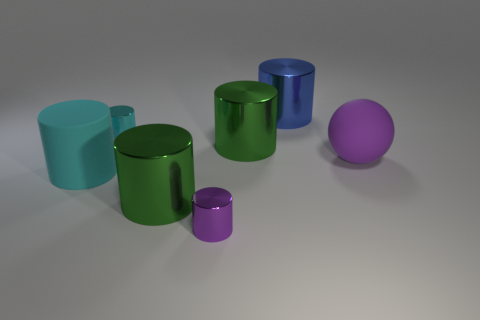Is the number of blue shiny objects that are behind the large cyan cylinder less than the number of big purple spheres behind the blue object?
Your answer should be very brief. No. What is the shape of the large shiny object that is both in front of the cyan metallic cylinder and behind the large purple rubber thing?
Provide a succinct answer. Cylinder. There is a purple ball that is the same material as the big cyan thing; what size is it?
Your answer should be very brief. Large. There is a large rubber sphere; is it the same color as the small cylinder that is behind the large cyan thing?
Your response must be concise. No. There is a large thing that is both in front of the large sphere and to the right of the big cyan matte cylinder; what is its material?
Ensure brevity in your answer.  Metal. There is a object that is the same color as the large rubber cylinder; what is its size?
Make the answer very short. Small. Is the shape of the green thing that is to the right of the purple cylinder the same as the big rubber object on the right side of the tiny purple thing?
Keep it short and to the point. No. Are any big yellow balls visible?
Provide a short and direct response. No. What is the color of the other small thing that is the same shape as the purple shiny object?
Your answer should be compact. Cyan. What is the color of the rubber thing that is the same size as the sphere?
Give a very brief answer. Cyan. 